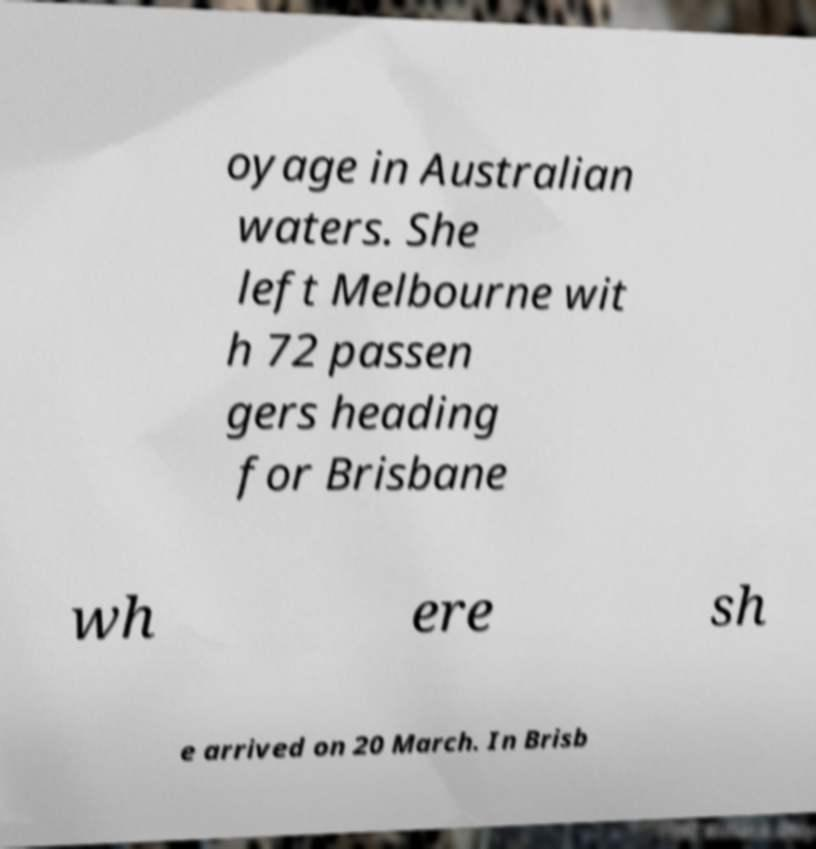What messages or text are displayed in this image? I need them in a readable, typed format. oyage in Australian waters. She left Melbourne wit h 72 passen gers heading for Brisbane wh ere sh e arrived on 20 March. In Brisb 